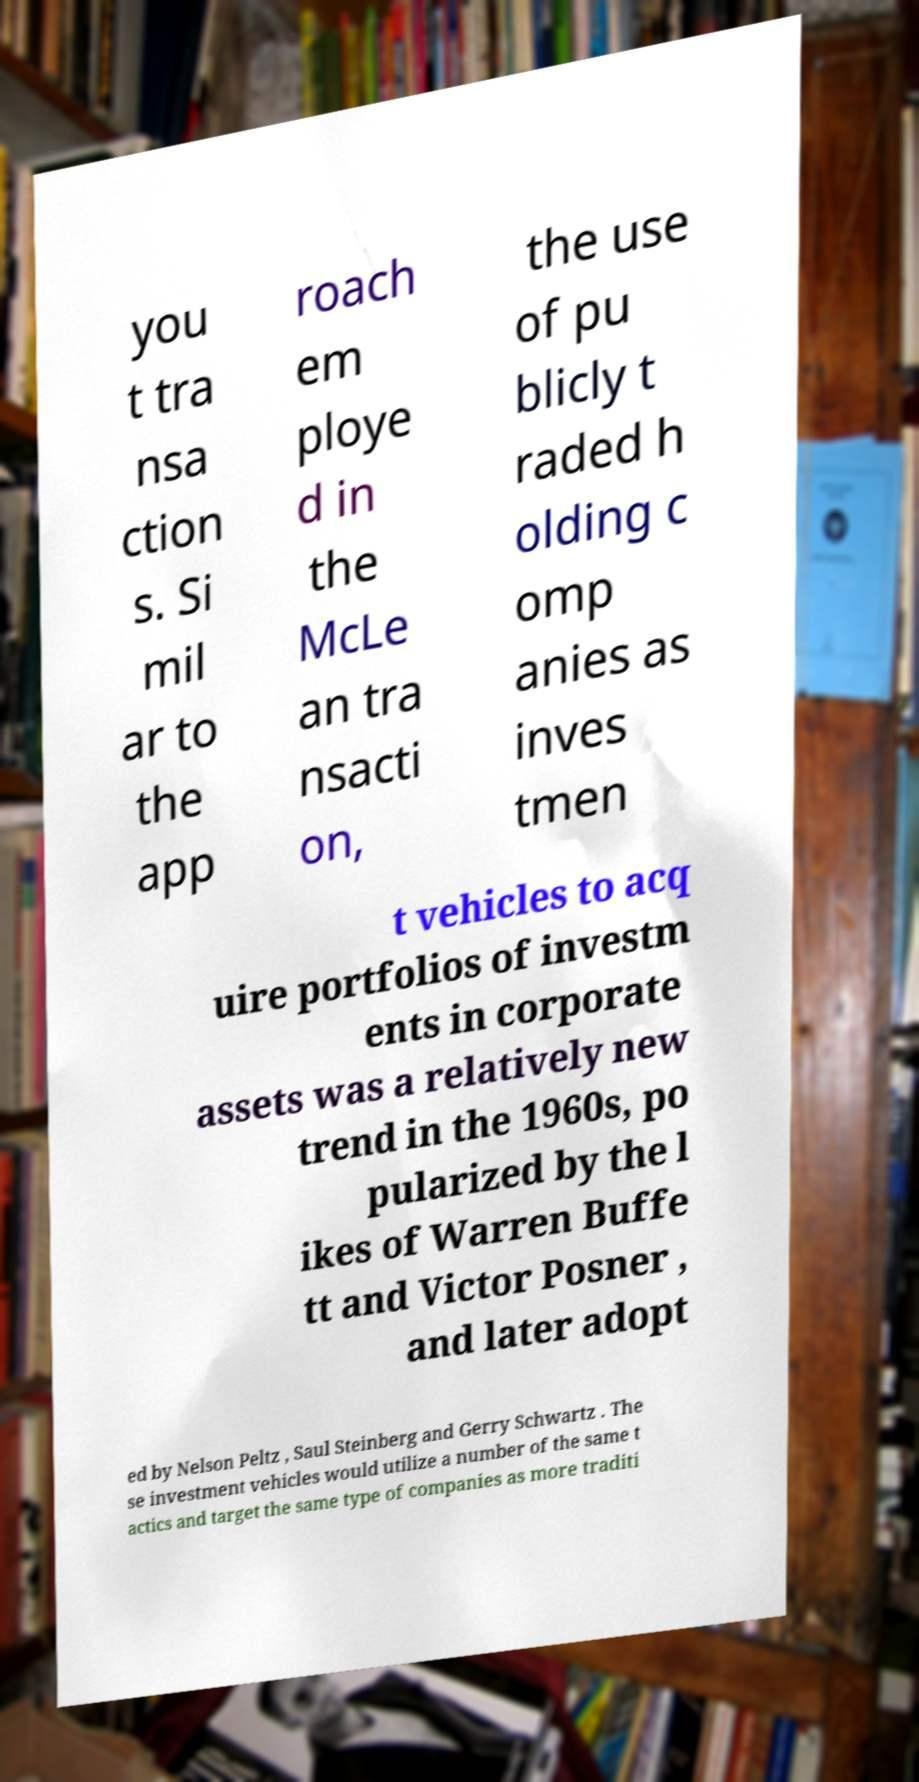There's text embedded in this image that I need extracted. Can you transcribe it verbatim? you t tra nsa ction s. Si mil ar to the app roach em ploye d in the McLe an tra nsacti on, the use of pu blicly t raded h olding c omp anies as inves tmen t vehicles to acq uire portfolios of investm ents in corporate assets was a relatively new trend in the 1960s, po pularized by the l ikes of Warren Buffe tt and Victor Posner , and later adopt ed by Nelson Peltz , Saul Steinberg and Gerry Schwartz . The se investment vehicles would utilize a number of the same t actics and target the same type of companies as more traditi 